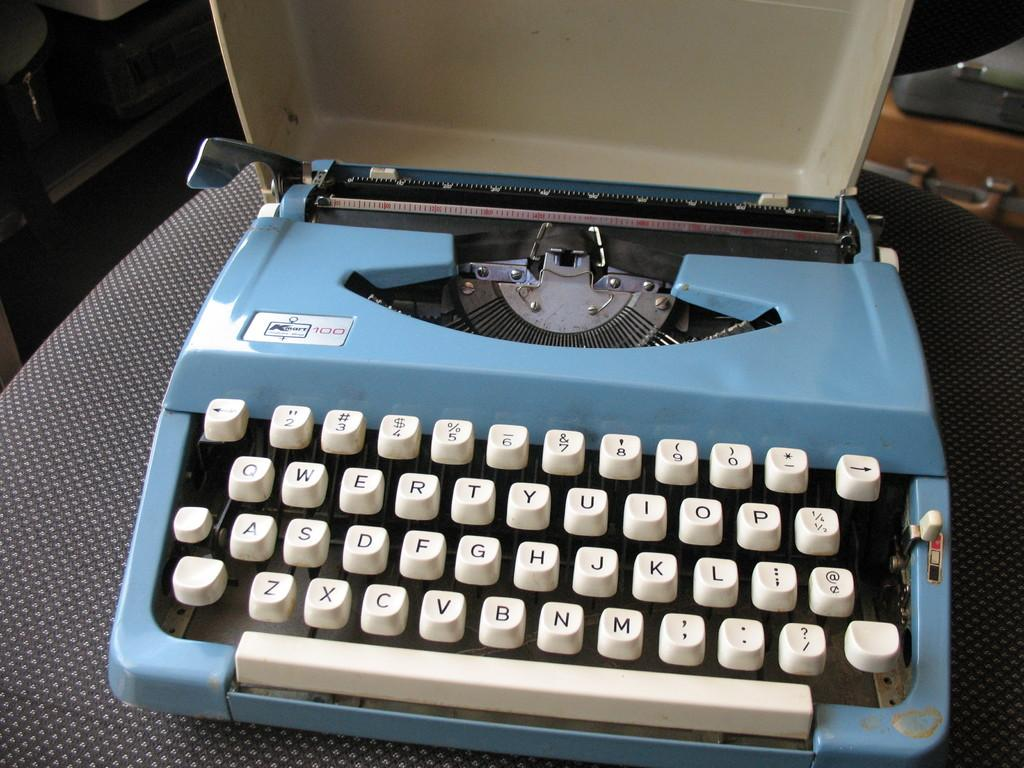<image>
Relay a brief, clear account of the picture shown. an old k-mart typewriter sitting on a chair 